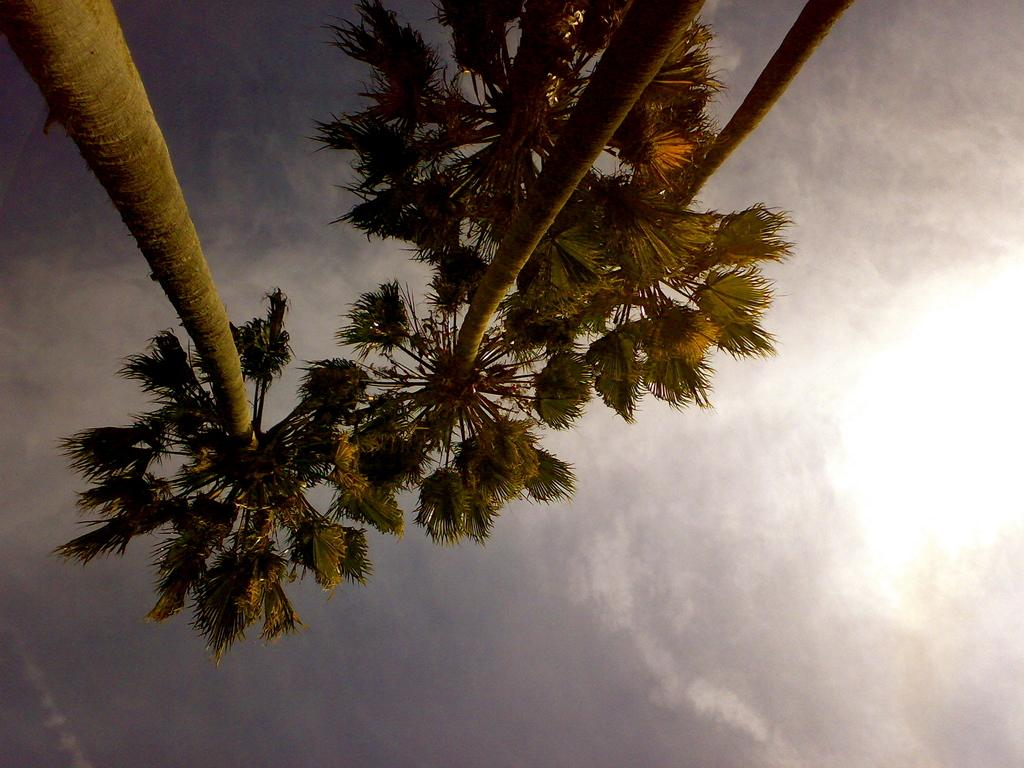What type of trees can be seen in the image? There are coconut trees in the image. What is visible in the background of the image? The sky is visible in the background of the image. What can be observed in the sky? Clouds are present in the sky. How many tubes of toothpaste are hanging from the coconut trees in the image? There are no tubes of toothpaste present in the image. How many girls can be seen playing near the coconut trees in the image? There are no girls present in the image; it only features coconut trees and the sky. 